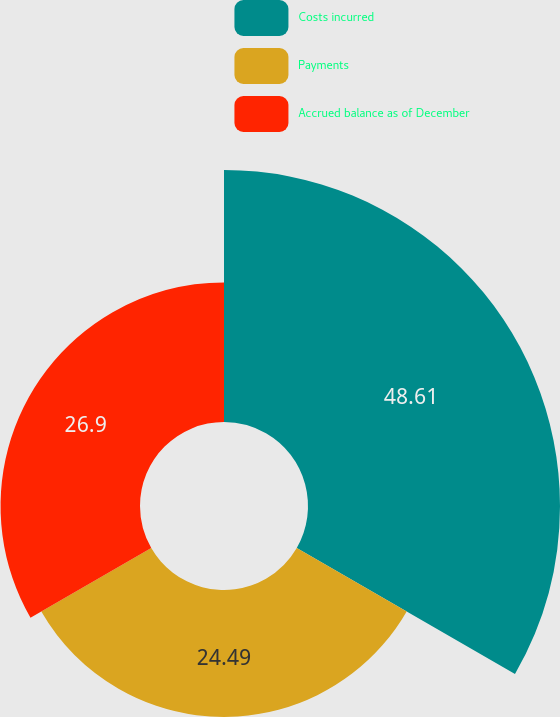Convert chart to OTSL. <chart><loc_0><loc_0><loc_500><loc_500><pie_chart><fcel>Costs incurred<fcel>Payments<fcel>Accrued balance as of December<nl><fcel>48.61%<fcel>24.49%<fcel>26.9%<nl></chart> 